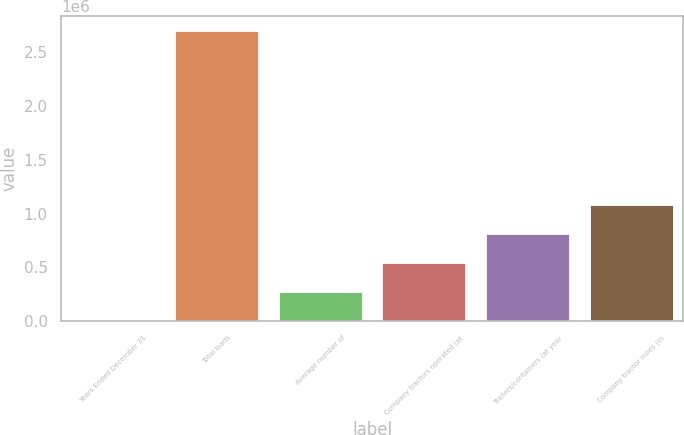<chart> <loc_0><loc_0><loc_500><loc_500><bar_chart><fcel>Years Ended December 31<fcel>Total loads<fcel>Average number of<fcel>Company tractors operated (at<fcel>Trailers/containers (at year<fcel>Company tractor miles (in<nl><fcel>2000<fcel>2.69758e+06<fcel>271558<fcel>541116<fcel>810675<fcel>1.08023e+06<nl></chart> 